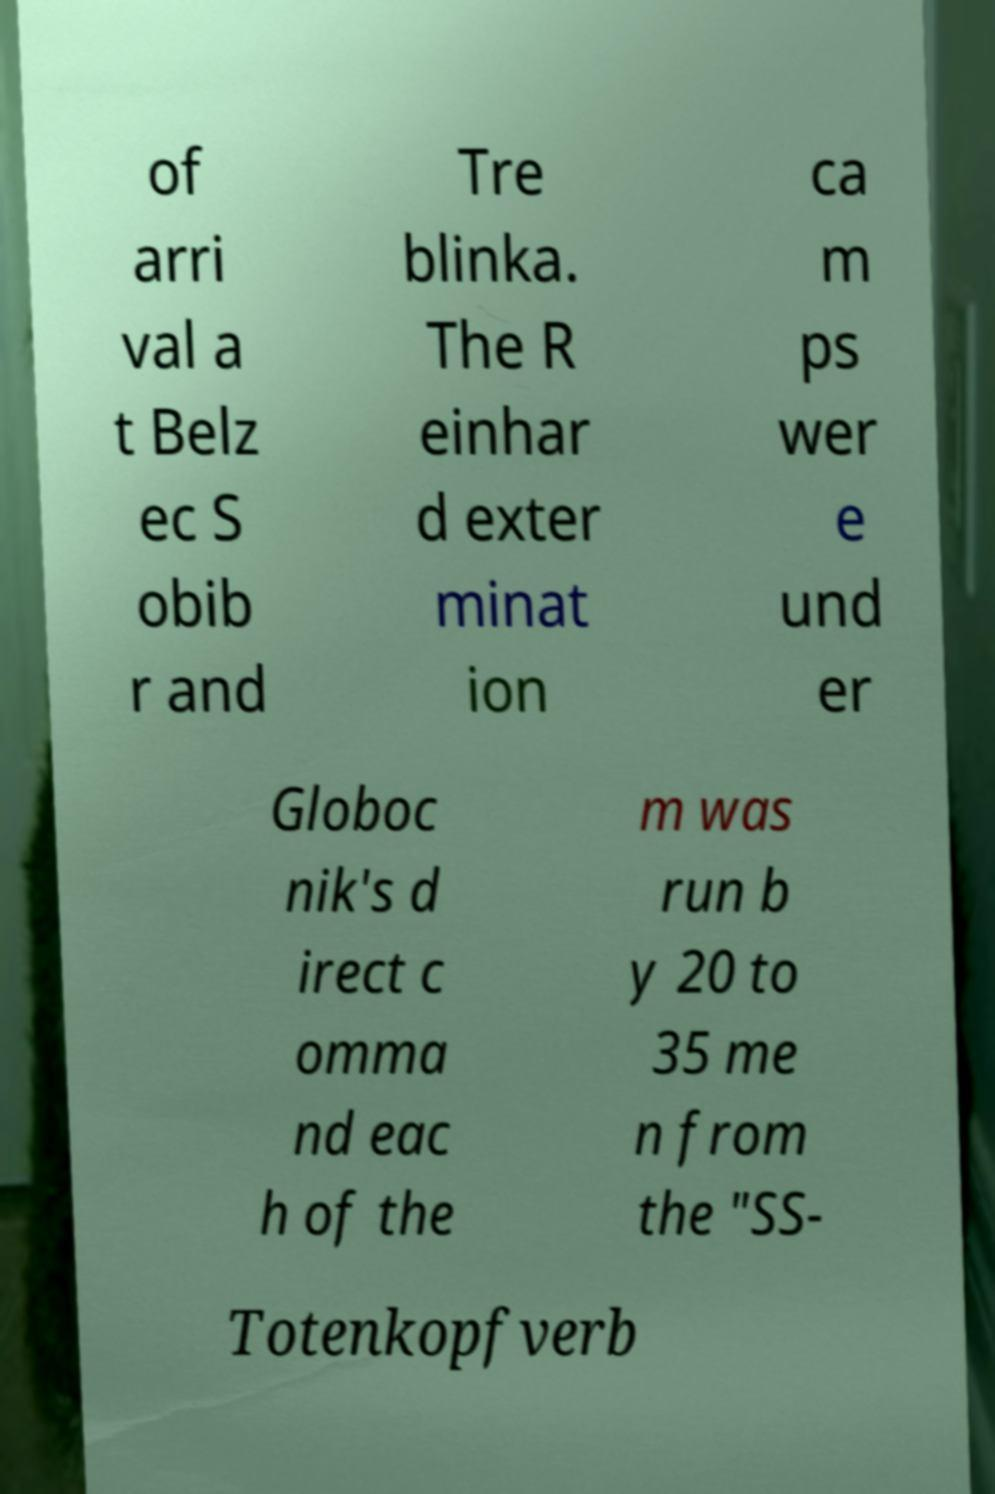Could you assist in decoding the text presented in this image and type it out clearly? of arri val a t Belz ec S obib r and Tre blinka. The R einhar d exter minat ion ca m ps wer e und er Globoc nik's d irect c omma nd eac h of the m was run b y 20 to 35 me n from the "SS- Totenkopfverb 